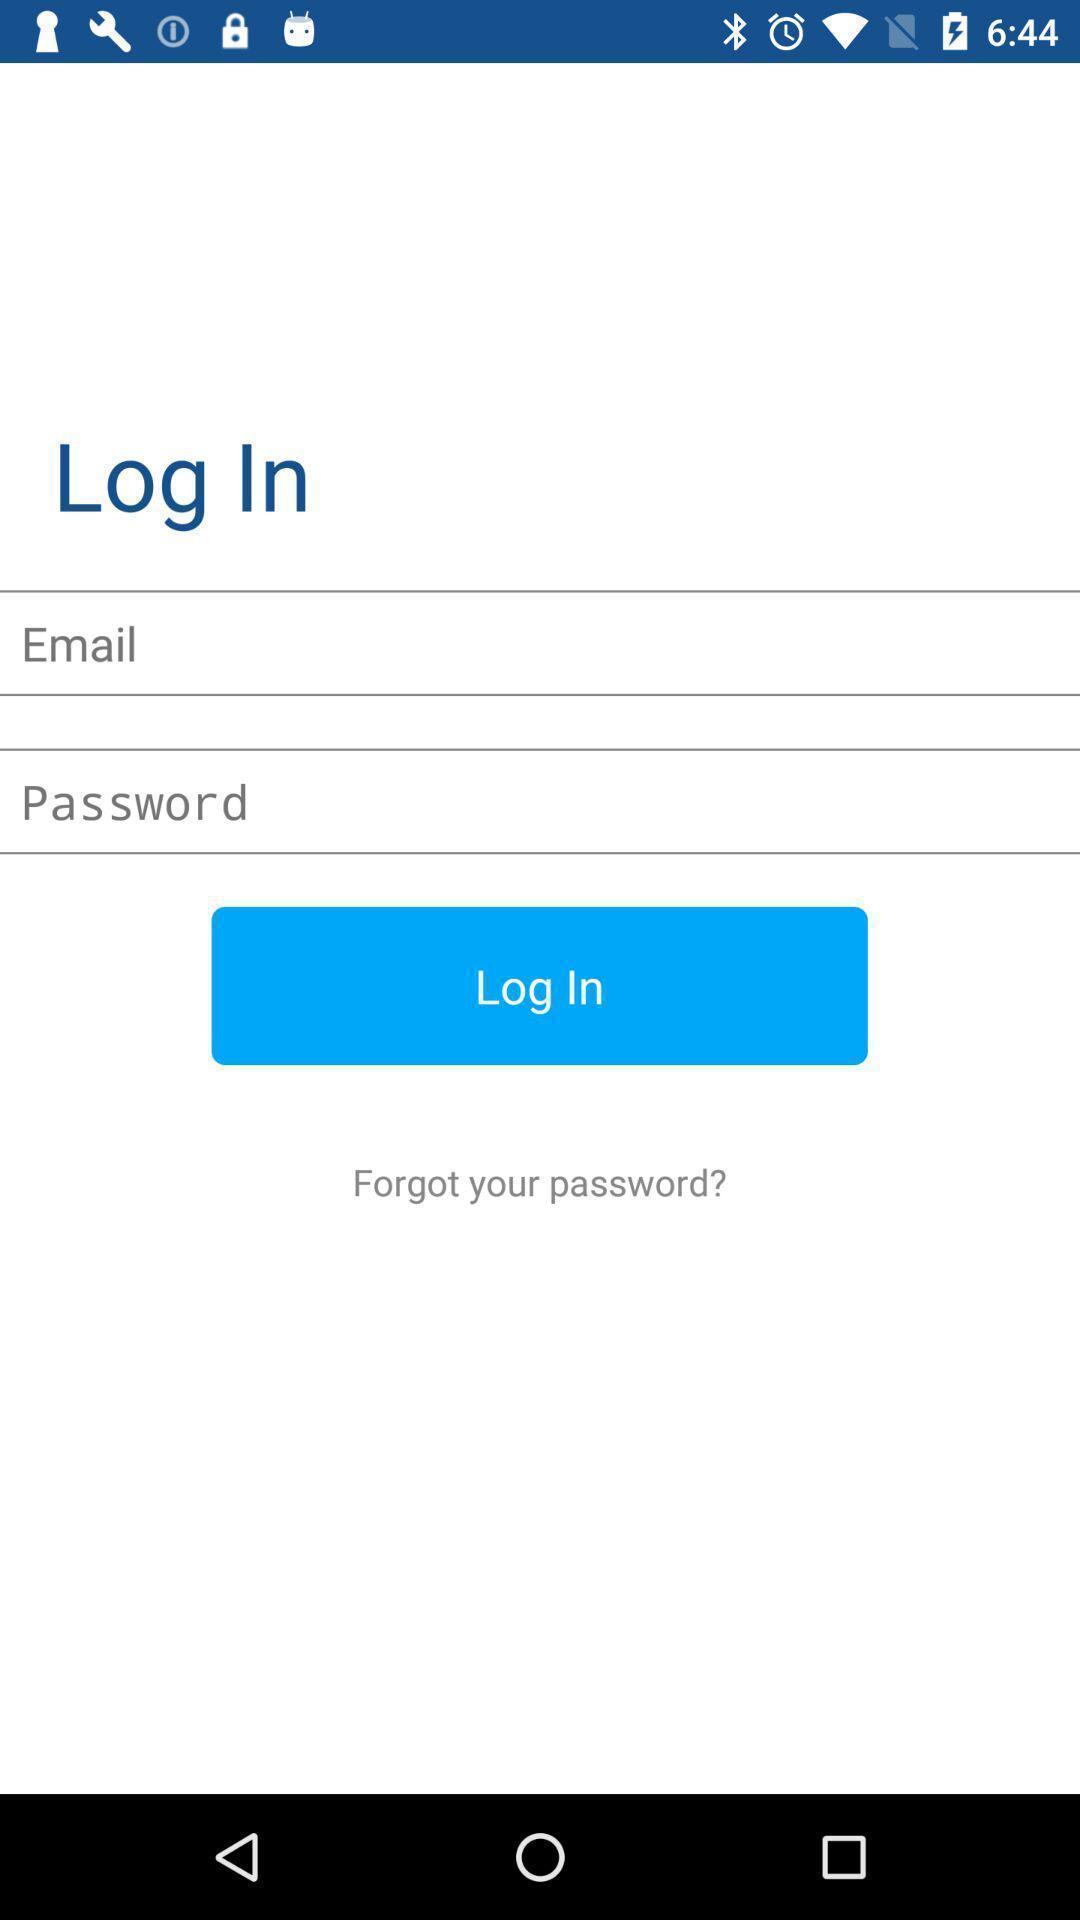Tell me about the visual elements in this screen capture. Login screen of mileage tracking app. 